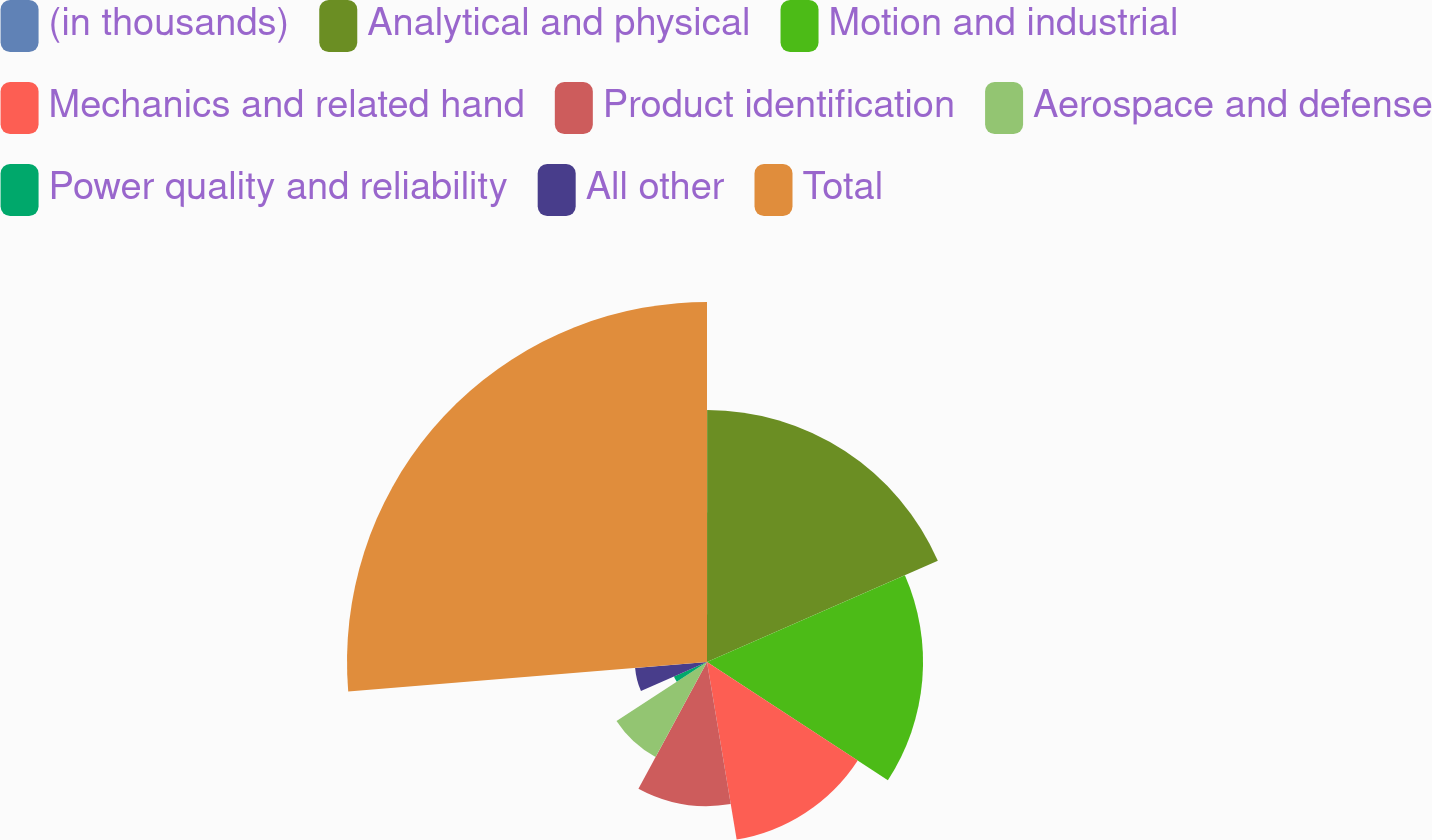Convert chart. <chart><loc_0><loc_0><loc_500><loc_500><pie_chart><fcel>(in thousands)<fcel>Analytical and physical<fcel>Motion and industrial<fcel>Mechanics and related hand<fcel>Product identification<fcel>Aerospace and defense<fcel>Power quality and reliability<fcel>All other<fcel>Total<nl><fcel>0.01%<fcel>18.42%<fcel>15.79%<fcel>13.16%<fcel>10.53%<fcel>7.9%<fcel>2.64%<fcel>5.27%<fcel>26.31%<nl></chart> 